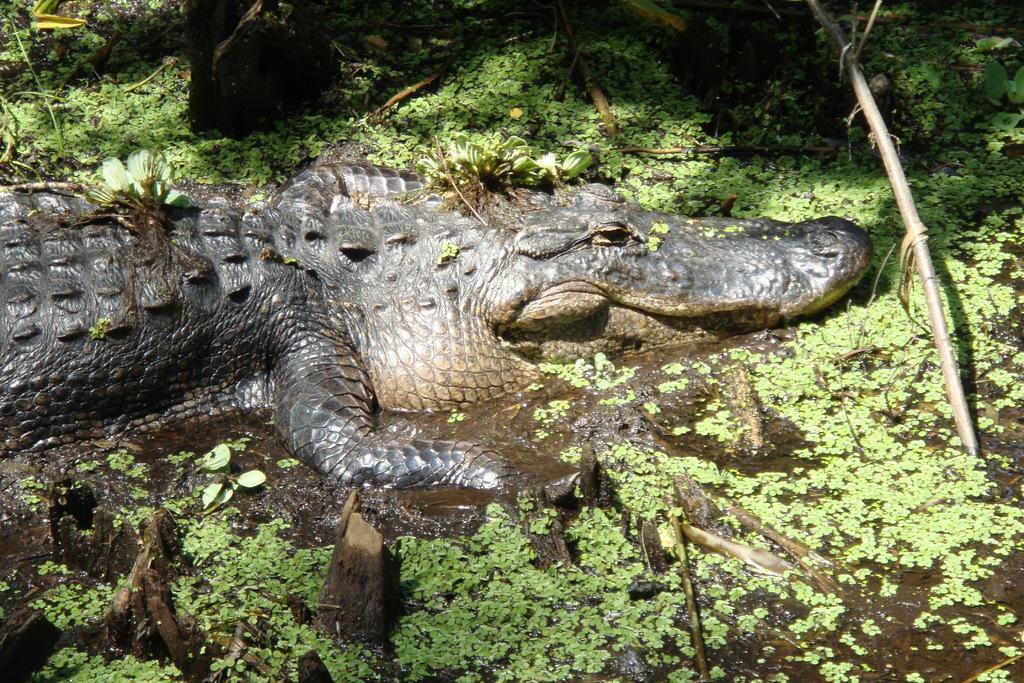Could you give a brief overview of what you see in this image? In this image there is a crocodile. At the bottom there is water and we can see logs. There is grass. 